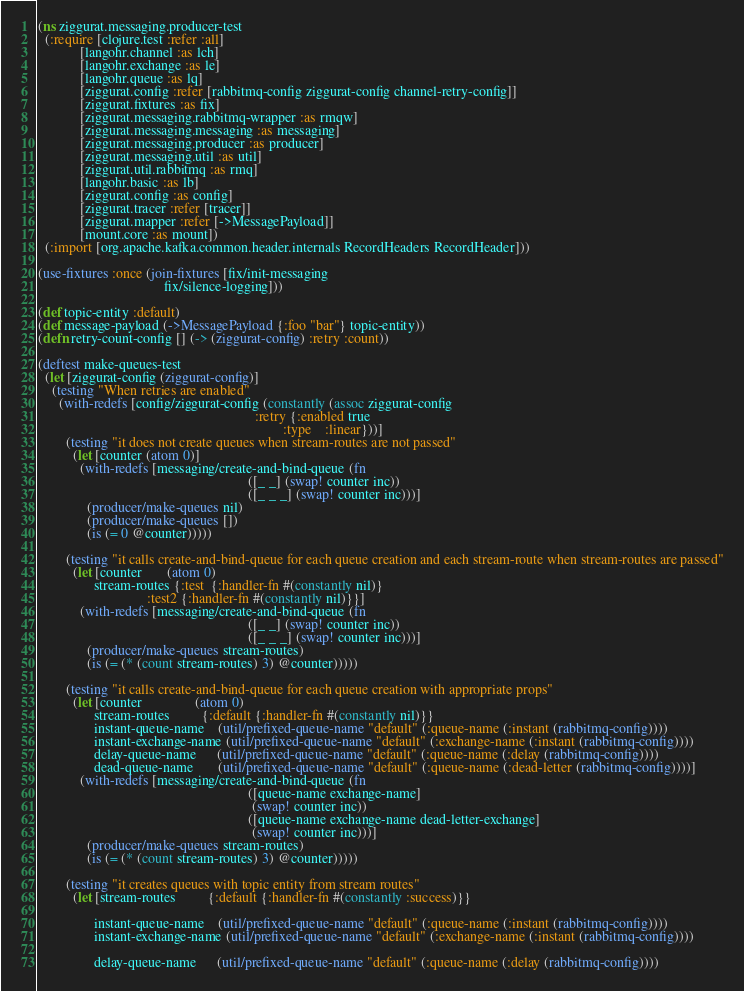<code> <loc_0><loc_0><loc_500><loc_500><_Clojure_>(ns ziggurat.messaging.producer-test
  (:require [clojure.test :refer :all]
            [langohr.channel :as lch]
            [langohr.exchange :as le]
            [langohr.queue :as lq]
            [ziggurat.config :refer [rabbitmq-config ziggurat-config channel-retry-config]]
            [ziggurat.fixtures :as fix]
            [ziggurat.messaging.rabbitmq-wrapper :as rmqw]
            [ziggurat.messaging.messaging :as messaging]
            [ziggurat.messaging.producer :as producer]
            [ziggurat.messaging.util :as util]
            [ziggurat.util.rabbitmq :as rmq]
            [langohr.basic :as lb]
            [ziggurat.config :as config]
            [ziggurat.tracer :refer [tracer]]
            [ziggurat.mapper :refer [->MessagePayload]]
            [mount.core :as mount])
  (:import [org.apache.kafka.common.header.internals RecordHeaders RecordHeader]))

(use-fixtures :once (join-fixtures [fix/init-messaging
                                    fix/silence-logging]))

(def topic-entity :default)
(def message-payload (->MessagePayload {:foo "bar"} topic-entity))
(defn retry-count-config [] (-> (ziggurat-config) :retry :count))

(deftest make-queues-test
  (let [ziggurat-config (ziggurat-config)]
    (testing "When retries are enabled"
      (with-redefs [config/ziggurat-config (constantly (assoc ziggurat-config
                                                              :retry {:enabled true
                                                                      :type    :linear}))]
        (testing "it does not create queues when stream-routes are not passed"
          (let [counter (atom 0)]
            (with-redefs [messaging/create-and-bind-queue (fn
                                                            ([_ _] (swap! counter inc))
                                                            ([_ _ _] (swap! counter inc)))]
              (producer/make-queues nil)
              (producer/make-queues [])
              (is (= 0 @counter)))))

        (testing "it calls create-and-bind-queue for each queue creation and each stream-route when stream-routes are passed"
          (let [counter       (atom 0)
                stream-routes {:test  {:handler-fn #(constantly nil)}
                               :test2 {:handler-fn #(constantly nil)}}]
            (with-redefs [messaging/create-and-bind-queue (fn
                                                            ([_ _] (swap! counter inc))
                                                            ([_ _ _] (swap! counter inc)))]
              (producer/make-queues stream-routes)
              (is (= (* (count stream-routes) 3) @counter)))))

        (testing "it calls create-and-bind-queue for each queue creation with appropriate props"
          (let [counter               (atom 0)
                stream-routes         {:default {:handler-fn #(constantly nil)}}
                instant-queue-name    (util/prefixed-queue-name "default" (:queue-name (:instant (rabbitmq-config))))
                instant-exchange-name (util/prefixed-queue-name "default" (:exchange-name (:instant (rabbitmq-config))))
                delay-queue-name      (util/prefixed-queue-name "default" (:queue-name (:delay (rabbitmq-config))))
                dead-queue-name       (util/prefixed-queue-name "default" (:queue-name (:dead-letter (rabbitmq-config))))]
            (with-redefs [messaging/create-and-bind-queue (fn
                                                            ([queue-name exchange-name]
                                                             (swap! counter inc))
                                                            ([queue-name exchange-name dead-letter-exchange]
                                                             (swap! counter inc)))]
              (producer/make-queues stream-routes)
              (is (= (* (count stream-routes) 3) @counter)))))

        (testing "it creates queues with topic entity from stream routes"
          (let [stream-routes         {:default {:handler-fn #(constantly :success)}}

                instant-queue-name    (util/prefixed-queue-name "default" (:queue-name (:instant (rabbitmq-config))))
                instant-exchange-name (util/prefixed-queue-name "default" (:exchange-name (:instant (rabbitmq-config))))

                delay-queue-name      (util/prefixed-queue-name "default" (:queue-name (:delay (rabbitmq-config))))</code> 